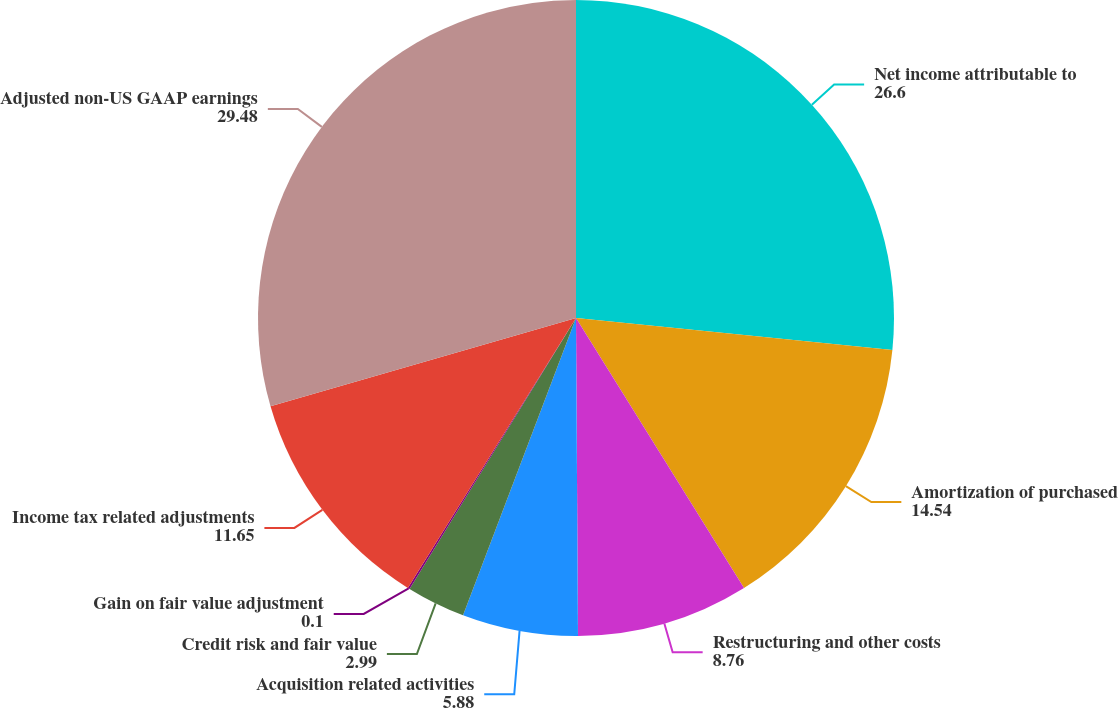<chart> <loc_0><loc_0><loc_500><loc_500><pie_chart><fcel>Net income attributable to<fcel>Amortization of purchased<fcel>Restructuring and other costs<fcel>Acquisition related activities<fcel>Credit risk and fair value<fcel>Gain on fair value adjustment<fcel>Income tax related adjustments<fcel>Adjusted non-US GAAP earnings<nl><fcel>26.6%<fcel>14.54%<fcel>8.76%<fcel>5.88%<fcel>2.99%<fcel>0.1%<fcel>11.65%<fcel>29.48%<nl></chart> 